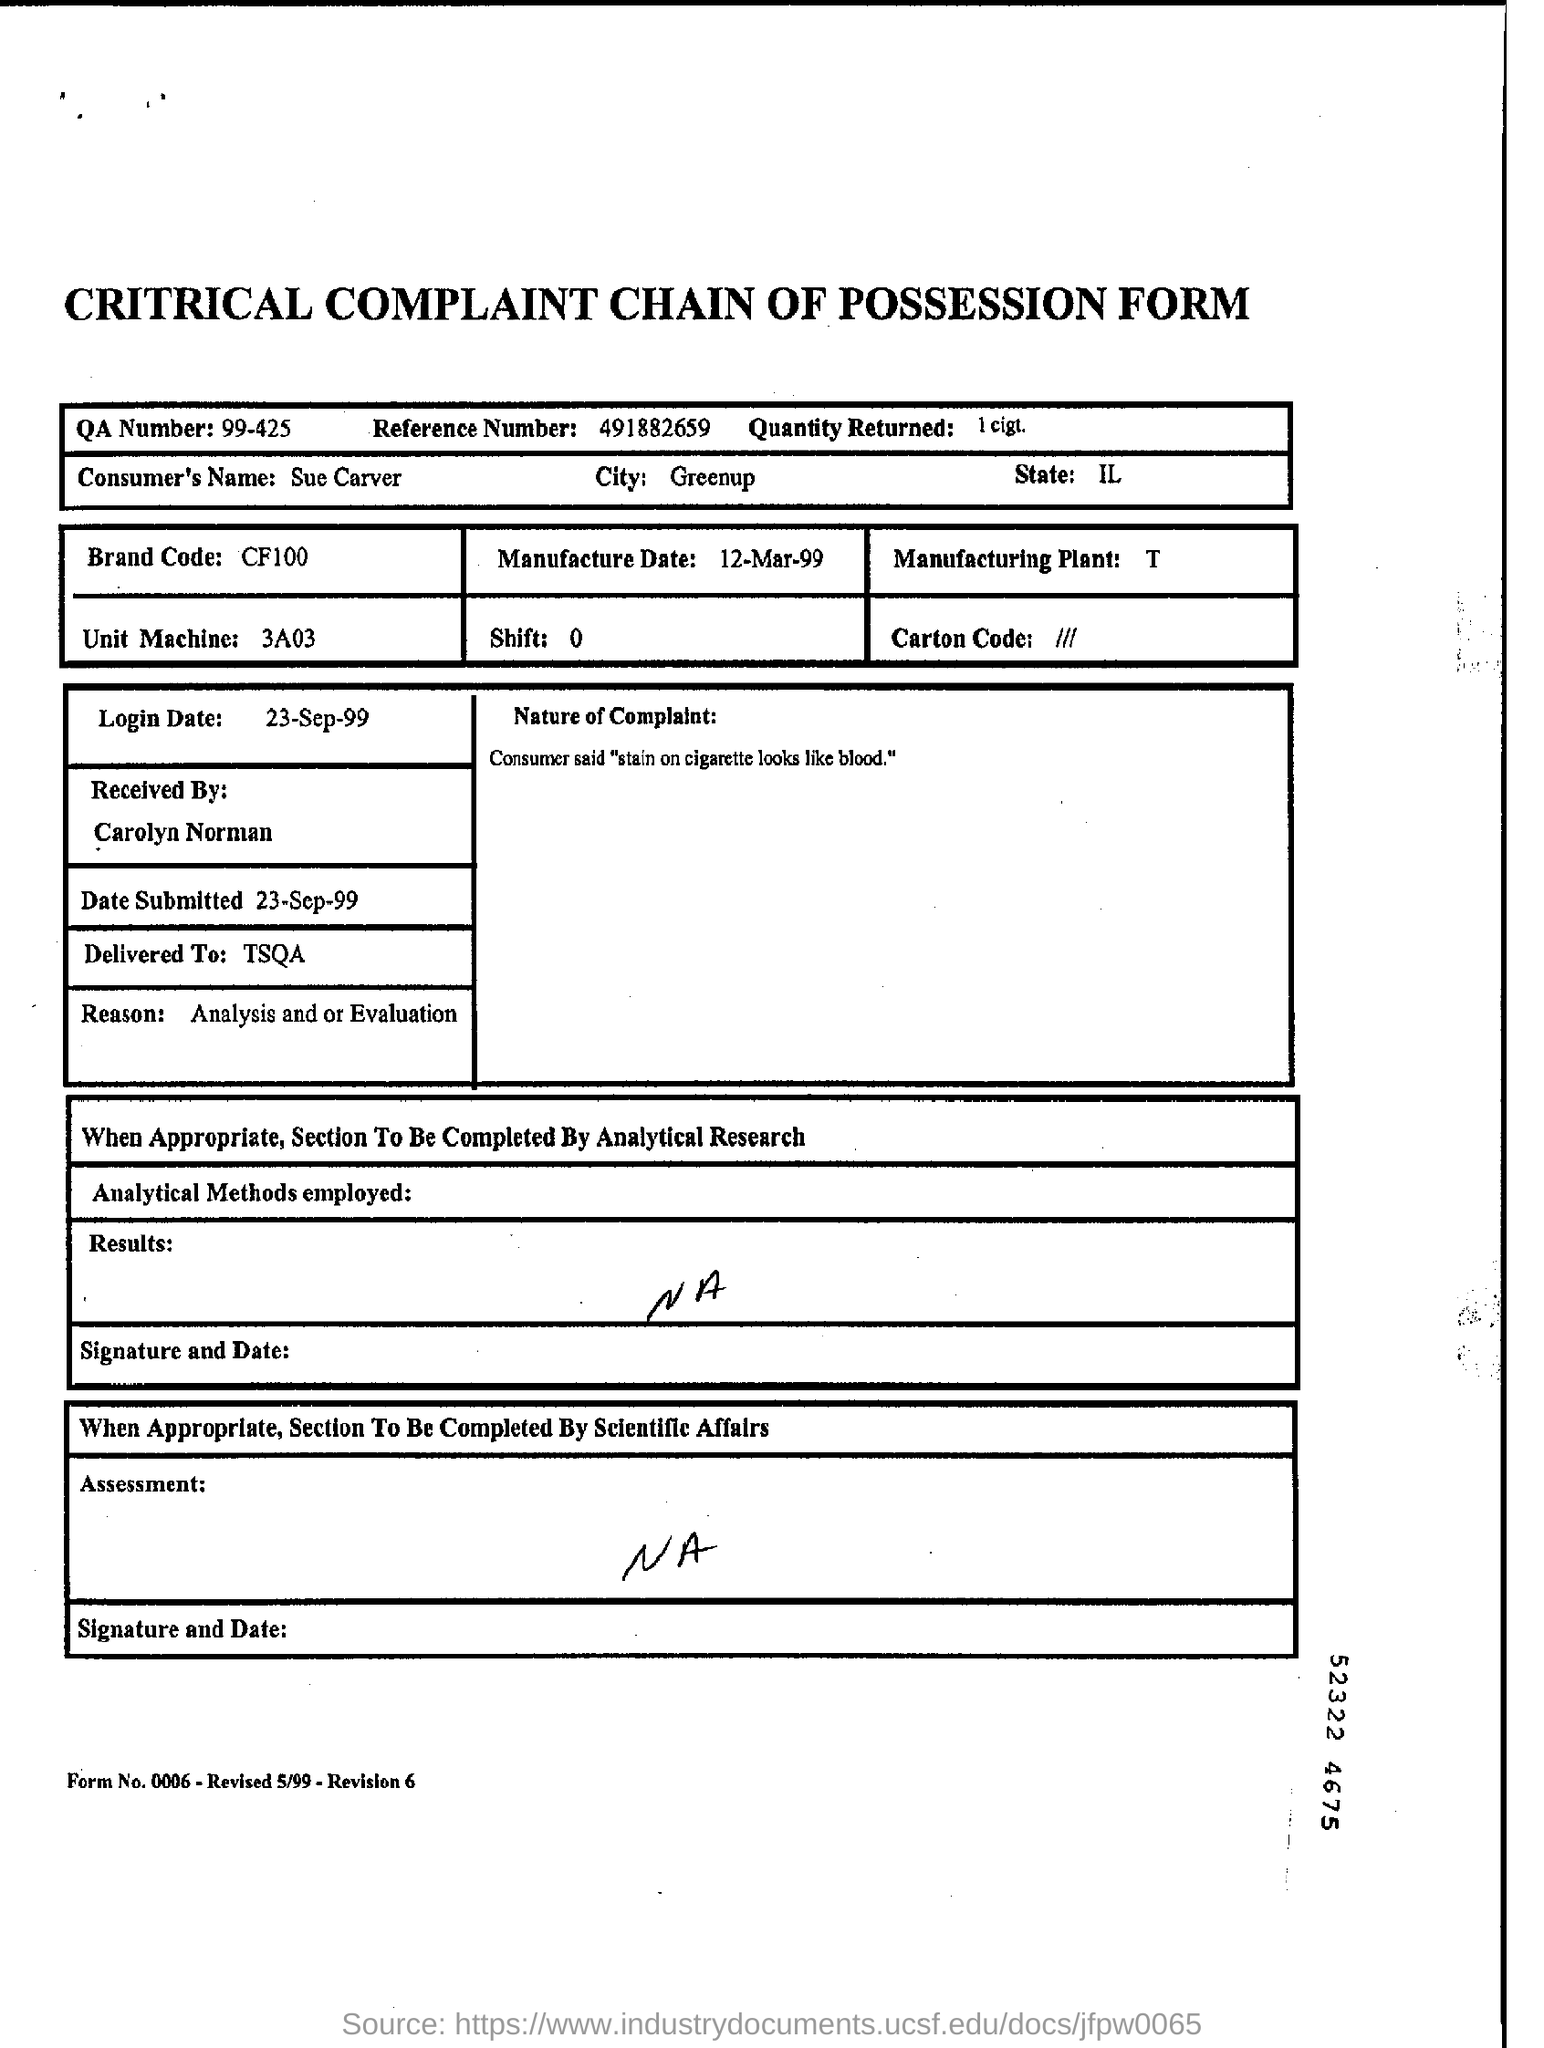What is the QA Number?
Make the answer very short. 99-425. What is the Reference Number?
Offer a very short reply. 491882659. What is the Quantity Returned?
Keep it short and to the point. 1 cigt. What is the City?
Offer a terse response. Greenup. What is the Unit Machine?
Your response must be concise. 3A03. What is the Brand Code?
Provide a short and direct response. CF100. What is the Login Date?
Give a very brief answer. 23-Sep-99. What is Delivered To?
Give a very brief answer. TSQA. When is the Date Submitted?
Offer a terse response. 23-Sep-99. What is the State?
Make the answer very short. IL. 